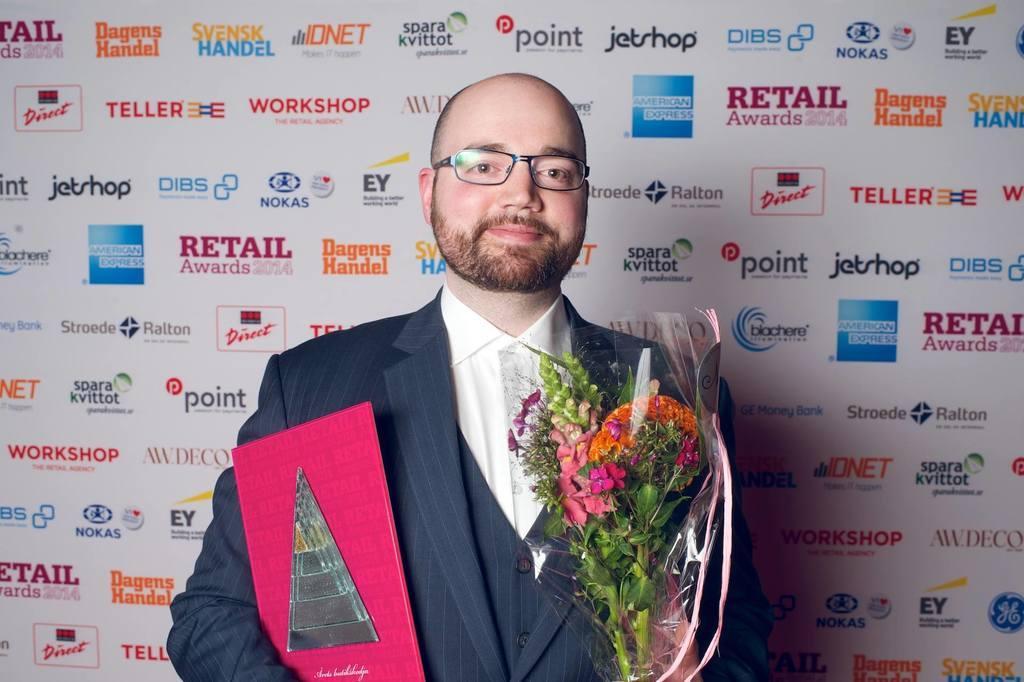Describe this image in one or two sentences. The man in the middle of the picture wearing a white shirt and blue blazer is holding a pink book in one of his hands. In the other hand, he is holding a bouquet. He is wearing spectacles. He is smiling. Behind him, we see a white banner containing logos and text in different colors. 